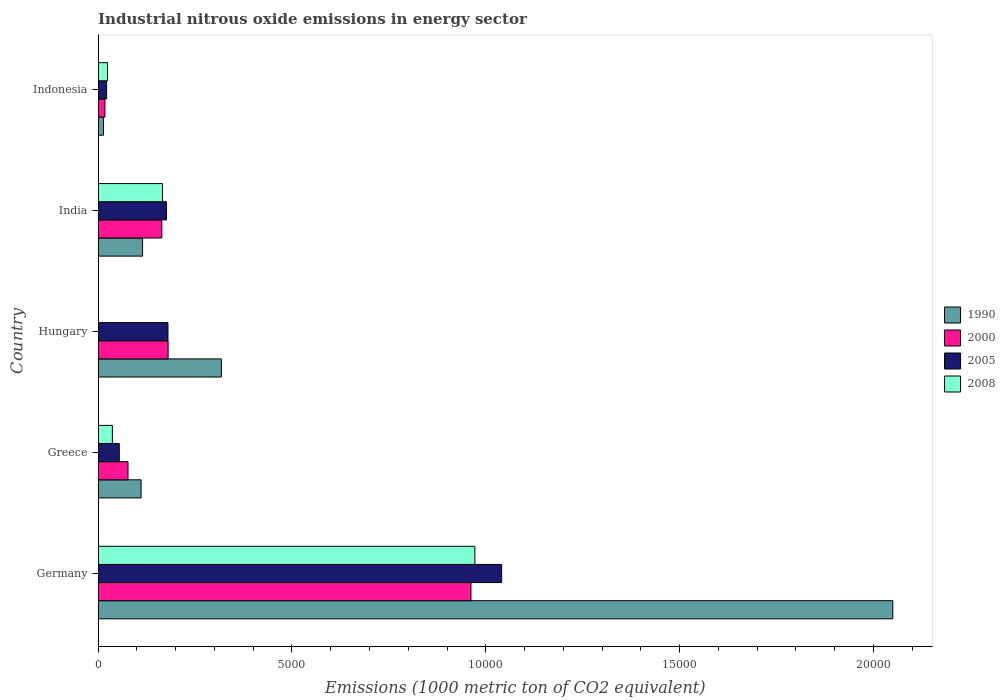How many bars are there on the 3rd tick from the top?
Your answer should be very brief. 4. How many bars are there on the 5th tick from the bottom?
Offer a terse response. 4. What is the label of the 2nd group of bars from the top?
Provide a short and direct response. India. In how many cases, is the number of bars for a given country not equal to the number of legend labels?
Give a very brief answer. 0. What is the amount of industrial nitrous oxide emitted in 2005 in Greece?
Ensure brevity in your answer.  545.8. Across all countries, what is the maximum amount of industrial nitrous oxide emitted in 1990?
Ensure brevity in your answer.  2.05e+04. Across all countries, what is the minimum amount of industrial nitrous oxide emitted in 1990?
Provide a short and direct response. 139.5. In which country was the amount of industrial nitrous oxide emitted in 1990 minimum?
Your answer should be very brief. Indonesia. What is the total amount of industrial nitrous oxide emitted in 2005 in the graph?
Provide a short and direct response. 1.47e+04. What is the difference between the amount of industrial nitrous oxide emitted in 2005 in India and that in Indonesia?
Offer a terse response. 1542.3. What is the difference between the amount of industrial nitrous oxide emitted in 1990 in Greece and the amount of industrial nitrous oxide emitted in 2000 in Germany?
Offer a very short reply. -8508.8. What is the average amount of industrial nitrous oxide emitted in 2000 per country?
Give a very brief answer. 2802.68. What is the difference between the amount of industrial nitrous oxide emitted in 1990 and amount of industrial nitrous oxide emitted in 2000 in India?
Your answer should be very brief. -496.6. In how many countries, is the amount of industrial nitrous oxide emitted in 2008 greater than 8000 1000 metric ton?
Provide a short and direct response. 1. What is the ratio of the amount of industrial nitrous oxide emitted in 1990 in Germany to that in Greece?
Make the answer very short. 18.48. What is the difference between the highest and the second highest amount of industrial nitrous oxide emitted in 2008?
Provide a short and direct response. 8058.6. What is the difference between the highest and the lowest amount of industrial nitrous oxide emitted in 1990?
Make the answer very short. 2.04e+04. Is it the case that in every country, the sum of the amount of industrial nitrous oxide emitted in 2000 and amount of industrial nitrous oxide emitted in 2008 is greater than the sum of amount of industrial nitrous oxide emitted in 2005 and amount of industrial nitrous oxide emitted in 1990?
Provide a short and direct response. No. What does the 4th bar from the top in India represents?
Give a very brief answer. 1990. What does the 4th bar from the bottom in Indonesia represents?
Provide a short and direct response. 2008. Is it the case that in every country, the sum of the amount of industrial nitrous oxide emitted in 1990 and amount of industrial nitrous oxide emitted in 2008 is greater than the amount of industrial nitrous oxide emitted in 2005?
Your response must be concise. Yes. How many bars are there?
Your answer should be compact. 20. Are all the bars in the graph horizontal?
Keep it short and to the point. Yes. Does the graph contain grids?
Offer a terse response. No. Where does the legend appear in the graph?
Your response must be concise. Center right. What is the title of the graph?
Your response must be concise. Industrial nitrous oxide emissions in energy sector. Does "2002" appear as one of the legend labels in the graph?
Your response must be concise. No. What is the label or title of the X-axis?
Keep it short and to the point. Emissions (1000 metric ton of CO2 equivalent). What is the label or title of the Y-axis?
Your answer should be compact. Country. What is the Emissions (1000 metric ton of CO2 equivalent) in 1990 in Germany?
Offer a terse response. 2.05e+04. What is the Emissions (1000 metric ton of CO2 equivalent) in 2000 in Germany?
Ensure brevity in your answer.  9617.9. What is the Emissions (1000 metric ton of CO2 equivalent) of 2005 in Germany?
Offer a very short reply. 1.04e+04. What is the Emissions (1000 metric ton of CO2 equivalent) of 2008 in Germany?
Offer a very short reply. 9718.4. What is the Emissions (1000 metric ton of CO2 equivalent) of 1990 in Greece?
Your answer should be very brief. 1109.1. What is the Emissions (1000 metric ton of CO2 equivalent) in 2000 in Greece?
Ensure brevity in your answer.  771. What is the Emissions (1000 metric ton of CO2 equivalent) of 2005 in Greece?
Offer a very short reply. 545.8. What is the Emissions (1000 metric ton of CO2 equivalent) in 2008 in Greece?
Your response must be concise. 367.4. What is the Emissions (1000 metric ton of CO2 equivalent) of 1990 in Hungary?
Keep it short and to the point. 3178.6. What is the Emissions (1000 metric ton of CO2 equivalent) of 2000 in Hungary?
Offer a very short reply. 1805.4. What is the Emissions (1000 metric ton of CO2 equivalent) of 2005 in Hungary?
Keep it short and to the point. 1802. What is the Emissions (1000 metric ton of CO2 equivalent) in 2008 in Hungary?
Your answer should be compact. 6. What is the Emissions (1000 metric ton of CO2 equivalent) in 1990 in India?
Your answer should be compact. 1146.7. What is the Emissions (1000 metric ton of CO2 equivalent) of 2000 in India?
Provide a short and direct response. 1643.3. What is the Emissions (1000 metric ton of CO2 equivalent) in 2005 in India?
Provide a short and direct response. 1761.9. What is the Emissions (1000 metric ton of CO2 equivalent) in 2008 in India?
Offer a very short reply. 1659.8. What is the Emissions (1000 metric ton of CO2 equivalent) of 1990 in Indonesia?
Keep it short and to the point. 139.5. What is the Emissions (1000 metric ton of CO2 equivalent) in 2000 in Indonesia?
Your answer should be very brief. 175.8. What is the Emissions (1000 metric ton of CO2 equivalent) of 2005 in Indonesia?
Keep it short and to the point. 219.6. What is the Emissions (1000 metric ton of CO2 equivalent) in 2008 in Indonesia?
Offer a very short reply. 243.3. Across all countries, what is the maximum Emissions (1000 metric ton of CO2 equivalent) of 1990?
Offer a terse response. 2.05e+04. Across all countries, what is the maximum Emissions (1000 metric ton of CO2 equivalent) of 2000?
Ensure brevity in your answer.  9617.9. Across all countries, what is the maximum Emissions (1000 metric ton of CO2 equivalent) in 2005?
Your answer should be very brief. 1.04e+04. Across all countries, what is the maximum Emissions (1000 metric ton of CO2 equivalent) of 2008?
Provide a short and direct response. 9718.4. Across all countries, what is the minimum Emissions (1000 metric ton of CO2 equivalent) of 1990?
Provide a short and direct response. 139.5. Across all countries, what is the minimum Emissions (1000 metric ton of CO2 equivalent) in 2000?
Ensure brevity in your answer.  175.8. Across all countries, what is the minimum Emissions (1000 metric ton of CO2 equivalent) of 2005?
Give a very brief answer. 219.6. What is the total Emissions (1000 metric ton of CO2 equivalent) in 1990 in the graph?
Your answer should be very brief. 2.61e+04. What is the total Emissions (1000 metric ton of CO2 equivalent) in 2000 in the graph?
Make the answer very short. 1.40e+04. What is the total Emissions (1000 metric ton of CO2 equivalent) of 2005 in the graph?
Offer a terse response. 1.47e+04. What is the total Emissions (1000 metric ton of CO2 equivalent) in 2008 in the graph?
Offer a terse response. 1.20e+04. What is the difference between the Emissions (1000 metric ton of CO2 equivalent) in 1990 in Germany and that in Greece?
Keep it short and to the point. 1.94e+04. What is the difference between the Emissions (1000 metric ton of CO2 equivalent) of 2000 in Germany and that in Greece?
Offer a terse response. 8846.9. What is the difference between the Emissions (1000 metric ton of CO2 equivalent) of 2005 in Germany and that in Greece?
Your answer should be compact. 9863.1. What is the difference between the Emissions (1000 metric ton of CO2 equivalent) of 2008 in Germany and that in Greece?
Your response must be concise. 9351. What is the difference between the Emissions (1000 metric ton of CO2 equivalent) of 1990 in Germany and that in Hungary?
Provide a succinct answer. 1.73e+04. What is the difference between the Emissions (1000 metric ton of CO2 equivalent) in 2000 in Germany and that in Hungary?
Provide a short and direct response. 7812.5. What is the difference between the Emissions (1000 metric ton of CO2 equivalent) of 2005 in Germany and that in Hungary?
Make the answer very short. 8606.9. What is the difference between the Emissions (1000 metric ton of CO2 equivalent) of 2008 in Germany and that in Hungary?
Provide a succinct answer. 9712.4. What is the difference between the Emissions (1000 metric ton of CO2 equivalent) in 1990 in Germany and that in India?
Offer a terse response. 1.94e+04. What is the difference between the Emissions (1000 metric ton of CO2 equivalent) of 2000 in Germany and that in India?
Provide a succinct answer. 7974.6. What is the difference between the Emissions (1000 metric ton of CO2 equivalent) of 2005 in Germany and that in India?
Make the answer very short. 8647. What is the difference between the Emissions (1000 metric ton of CO2 equivalent) in 2008 in Germany and that in India?
Ensure brevity in your answer.  8058.6. What is the difference between the Emissions (1000 metric ton of CO2 equivalent) in 1990 in Germany and that in Indonesia?
Provide a short and direct response. 2.04e+04. What is the difference between the Emissions (1000 metric ton of CO2 equivalent) in 2000 in Germany and that in Indonesia?
Provide a succinct answer. 9442.1. What is the difference between the Emissions (1000 metric ton of CO2 equivalent) in 2005 in Germany and that in Indonesia?
Give a very brief answer. 1.02e+04. What is the difference between the Emissions (1000 metric ton of CO2 equivalent) in 2008 in Germany and that in Indonesia?
Give a very brief answer. 9475.1. What is the difference between the Emissions (1000 metric ton of CO2 equivalent) of 1990 in Greece and that in Hungary?
Your answer should be compact. -2069.5. What is the difference between the Emissions (1000 metric ton of CO2 equivalent) in 2000 in Greece and that in Hungary?
Make the answer very short. -1034.4. What is the difference between the Emissions (1000 metric ton of CO2 equivalent) in 2005 in Greece and that in Hungary?
Keep it short and to the point. -1256.2. What is the difference between the Emissions (1000 metric ton of CO2 equivalent) in 2008 in Greece and that in Hungary?
Provide a succinct answer. 361.4. What is the difference between the Emissions (1000 metric ton of CO2 equivalent) in 1990 in Greece and that in India?
Your response must be concise. -37.6. What is the difference between the Emissions (1000 metric ton of CO2 equivalent) of 2000 in Greece and that in India?
Provide a short and direct response. -872.3. What is the difference between the Emissions (1000 metric ton of CO2 equivalent) in 2005 in Greece and that in India?
Provide a short and direct response. -1216.1. What is the difference between the Emissions (1000 metric ton of CO2 equivalent) of 2008 in Greece and that in India?
Offer a very short reply. -1292.4. What is the difference between the Emissions (1000 metric ton of CO2 equivalent) in 1990 in Greece and that in Indonesia?
Give a very brief answer. 969.6. What is the difference between the Emissions (1000 metric ton of CO2 equivalent) in 2000 in Greece and that in Indonesia?
Offer a terse response. 595.2. What is the difference between the Emissions (1000 metric ton of CO2 equivalent) of 2005 in Greece and that in Indonesia?
Ensure brevity in your answer.  326.2. What is the difference between the Emissions (1000 metric ton of CO2 equivalent) of 2008 in Greece and that in Indonesia?
Your response must be concise. 124.1. What is the difference between the Emissions (1000 metric ton of CO2 equivalent) in 1990 in Hungary and that in India?
Ensure brevity in your answer.  2031.9. What is the difference between the Emissions (1000 metric ton of CO2 equivalent) of 2000 in Hungary and that in India?
Ensure brevity in your answer.  162.1. What is the difference between the Emissions (1000 metric ton of CO2 equivalent) in 2005 in Hungary and that in India?
Keep it short and to the point. 40.1. What is the difference between the Emissions (1000 metric ton of CO2 equivalent) of 2008 in Hungary and that in India?
Provide a short and direct response. -1653.8. What is the difference between the Emissions (1000 metric ton of CO2 equivalent) in 1990 in Hungary and that in Indonesia?
Offer a terse response. 3039.1. What is the difference between the Emissions (1000 metric ton of CO2 equivalent) in 2000 in Hungary and that in Indonesia?
Provide a succinct answer. 1629.6. What is the difference between the Emissions (1000 metric ton of CO2 equivalent) of 2005 in Hungary and that in Indonesia?
Your answer should be compact. 1582.4. What is the difference between the Emissions (1000 metric ton of CO2 equivalent) of 2008 in Hungary and that in Indonesia?
Make the answer very short. -237.3. What is the difference between the Emissions (1000 metric ton of CO2 equivalent) in 1990 in India and that in Indonesia?
Keep it short and to the point. 1007.2. What is the difference between the Emissions (1000 metric ton of CO2 equivalent) of 2000 in India and that in Indonesia?
Your answer should be compact. 1467.5. What is the difference between the Emissions (1000 metric ton of CO2 equivalent) of 2005 in India and that in Indonesia?
Offer a very short reply. 1542.3. What is the difference between the Emissions (1000 metric ton of CO2 equivalent) of 2008 in India and that in Indonesia?
Give a very brief answer. 1416.5. What is the difference between the Emissions (1000 metric ton of CO2 equivalent) in 1990 in Germany and the Emissions (1000 metric ton of CO2 equivalent) in 2000 in Greece?
Your response must be concise. 1.97e+04. What is the difference between the Emissions (1000 metric ton of CO2 equivalent) of 1990 in Germany and the Emissions (1000 metric ton of CO2 equivalent) of 2005 in Greece?
Offer a terse response. 2.00e+04. What is the difference between the Emissions (1000 metric ton of CO2 equivalent) of 1990 in Germany and the Emissions (1000 metric ton of CO2 equivalent) of 2008 in Greece?
Give a very brief answer. 2.01e+04. What is the difference between the Emissions (1000 metric ton of CO2 equivalent) of 2000 in Germany and the Emissions (1000 metric ton of CO2 equivalent) of 2005 in Greece?
Offer a very short reply. 9072.1. What is the difference between the Emissions (1000 metric ton of CO2 equivalent) of 2000 in Germany and the Emissions (1000 metric ton of CO2 equivalent) of 2008 in Greece?
Keep it short and to the point. 9250.5. What is the difference between the Emissions (1000 metric ton of CO2 equivalent) of 2005 in Germany and the Emissions (1000 metric ton of CO2 equivalent) of 2008 in Greece?
Your response must be concise. 1.00e+04. What is the difference between the Emissions (1000 metric ton of CO2 equivalent) in 1990 in Germany and the Emissions (1000 metric ton of CO2 equivalent) in 2000 in Hungary?
Your response must be concise. 1.87e+04. What is the difference between the Emissions (1000 metric ton of CO2 equivalent) in 1990 in Germany and the Emissions (1000 metric ton of CO2 equivalent) in 2005 in Hungary?
Provide a short and direct response. 1.87e+04. What is the difference between the Emissions (1000 metric ton of CO2 equivalent) of 1990 in Germany and the Emissions (1000 metric ton of CO2 equivalent) of 2008 in Hungary?
Ensure brevity in your answer.  2.05e+04. What is the difference between the Emissions (1000 metric ton of CO2 equivalent) of 2000 in Germany and the Emissions (1000 metric ton of CO2 equivalent) of 2005 in Hungary?
Offer a terse response. 7815.9. What is the difference between the Emissions (1000 metric ton of CO2 equivalent) of 2000 in Germany and the Emissions (1000 metric ton of CO2 equivalent) of 2008 in Hungary?
Make the answer very short. 9611.9. What is the difference between the Emissions (1000 metric ton of CO2 equivalent) of 2005 in Germany and the Emissions (1000 metric ton of CO2 equivalent) of 2008 in Hungary?
Ensure brevity in your answer.  1.04e+04. What is the difference between the Emissions (1000 metric ton of CO2 equivalent) in 1990 in Germany and the Emissions (1000 metric ton of CO2 equivalent) in 2000 in India?
Keep it short and to the point. 1.89e+04. What is the difference between the Emissions (1000 metric ton of CO2 equivalent) of 1990 in Germany and the Emissions (1000 metric ton of CO2 equivalent) of 2005 in India?
Provide a succinct answer. 1.87e+04. What is the difference between the Emissions (1000 metric ton of CO2 equivalent) in 1990 in Germany and the Emissions (1000 metric ton of CO2 equivalent) in 2008 in India?
Ensure brevity in your answer.  1.88e+04. What is the difference between the Emissions (1000 metric ton of CO2 equivalent) in 2000 in Germany and the Emissions (1000 metric ton of CO2 equivalent) in 2005 in India?
Your answer should be very brief. 7856. What is the difference between the Emissions (1000 metric ton of CO2 equivalent) of 2000 in Germany and the Emissions (1000 metric ton of CO2 equivalent) of 2008 in India?
Offer a terse response. 7958.1. What is the difference between the Emissions (1000 metric ton of CO2 equivalent) of 2005 in Germany and the Emissions (1000 metric ton of CO2 equivalent) of 2008 in India?
Make the answer very short. 8749.1. What is the difference between the Emissions (1000 metric ton of CO2 equivalent) of 1990 in Germany and the Emissions (1000 metric ton of CO2 equivalent) of 2000 in Indonesia?
Your response must be concise. 2.03e+04. What is the difference between the Emissions (1000 metric ton of CO2 equivalent) in 1990 in Germany and the Emissions (1000 metric ton of CO2 equivalent) in 2005 in Indonesia?
Keep it short and to the point. 2.03e+04. What is the difference between the Emissions (1000 metric ton of CO2 equivalent) in 1990 in Germany and the Emissions (1000 metric ton of CO2 equivalent) in 2008 in Indonesia?
Your answer should be compact. 2.03e+04. What is the difference between the Emissions (1000 metric ton of CO2 equivalent) in 2000 in Germany and the Emissions (1000 metric ton of CO2 equivalent) in 2005 in Indonesia?
Offer a terse response. 9398.3. What is the difference between the Emissions (1000 metric ton of CO2 equivalent) of 2000 in Germany and the Emissions (1000 metric ton of CO2 equivalent) of 2008 in Indonesia?
Offer a terse response. 9374.6. What is the difference between the Emissions (1000 metric ton of CO2 equivalent) of 2005 in Germany and the Emissions (1000 metric ton of CO2 equivalent) of 2008 in Indonesia?
Ensure brevity in your answer.  1.02e+04. What is the difference between the Emissions (1000 metric ton of CO2 equivalent) of 1990 in Greece and the Emissions (1000 metric ton of CO2 equivalent) of 2000 in Hungary?
Give a very brief answer. -696.3. What is the difference between the Emissions (1000 metric ton of CO2 equivalent) of 1990 in Greece and the Emissions (1000 metric ton of CO2 equivalent) of 2005 in Hungary?
Provide a short and direct response. -692.9. What is the difference between the Emissions (1000 metric ton of CO2 equivalent) in 1990 in Greece and the Emissions (1000 metric ton of CO2 equivalent) in 2008 in Hungary?
Offer a terse response. 1103.1. What is the difference between the Emissions (1000 metric ton of CO2 equivalent) in 2000 in Greece and the Emissions (1000 metric ton of CO2 equivalent) in 2005 in Hungary?
Give a very brief answer. -1031. What is the difference between the Emissions (1000 metric ton of CO2 equivalent) of 2000 in Greece and the Emissions (1000 metric ton of CO2 equivalent) of 2008 in Hungary?
Give a very brief answer. 765. What is the difference between the Emissions (1000 metric ton of CO2 equivalent) of 2005 in Greece and the Emissions (1000 metric ton of CO2 equivalent) of 2008 in Hungary?
Your response must be concise. 539.8. What is the difference between the Emissions (1000 metric ton of CO2 equivalent) in 1990 in Greece and the Emissions (1000 metric ton of CO2 equivalent) in 2000 in India?
Offer a very short reply. -534.2. What is the difference between the Emissions (1000 metric ton of CO2 equivalent) in 1990 in Greece and the Emissions (1000 metric ton of CO2 equivalent) in 2005 in India?
Ensure brevity in your answer.  -652.8. What is the difference between the Emissions (1000 metric ton of CO2 equivalent) of 1990 in Greece and the Emissions (1000 metric ton of CO2 equivalent) of 2008 in India?
Provide a short and direct response. -550.7. What is the difference between the Emissions (1000 metric ton of CO2 equivalent) of 2000 in Greece and the Emissions (1000 metric ton of CO2 equivalent) of 2005 in India?
Make the answer very short. -990.9. What is the difference between the Emissions (1000 metric ton of CO2 equivalent) in 2000 in Greece and the Emissions (1000 metric ton of CO2 equivalent) in 2008 in India?
Your response must be concise. -888.8. What is the difference between the Emissions (1000 metric ton of CO2 equivalent) in 2005 in Greece and the Emissions (1000 metric ton of CO2 equivalent) in 2008 in India?
Provide a succinct answer. -1114. What is the difference between the Emissions (1000 metric ton of CO2 equivalent) in 1990 in Greece and the Emissions (1000 metric ton of CO2 equivalent) in 2000 in Indonesia?
Provide a succinct answer. 933.3. What is the difference between the Emissions (1000 metric ton of CO2 equivalent) in 1990 in Greece and the Emissions (1000 metric ton of CO2 equivalent) in 2005 in Indonesia?
Provide a short and direct response. 889.5. What is the difference between the Emissions (1000 metric ton of CO2 equivalent) of 1990 in Greece and the Emissions (1000 metric ton of CO2 equivalent) of 2008 in Indonesia?
Offer a terse response. 865.8. What is the difference between the Emissions (1000 metric ton of CO2 equivalent) of 2000 in Greece and the Emissions (1000 metric ton of CO2 equivalent) of 2005 in Indonesia?
Provide a short and direct response. 551.4. What is the difference between the Emissions (1000 metric ton of CO2 equivalent) of 2000 in Greece and the Emissions (1000 metric ton of CO2 equivalent) of 2008 in Indonesia?
Ensure brevity in your answer.  527.7. What is the difference between the Emissions (1000 metric ton of CO2 equivalent) of 2005 in Greece and the Emissions (1000 metric ton of CO2 equivalent) of 2008 in Indonesia?
Keep it short and to the point. 302.5. What is the difference between the Emissions (1000 metric ton of CO2 equivalent) in 1990 in Hungary and the Emissions (1000 metric ton of CO2 equivalent) in 2000 in India?
Your answer should be compact. 1535.3. What is the difference between the Emissions (1000 metric ton of CO2 equivalent) in 1990 in Hungary and the Emissions (1000 metric ton of CO2 equivalent) in 2005 in India?
Offer a terse response. 1416.7. What is the difference between the Emissions (1000 metric ton of CO2 equivalent) in 1990 in Hungary and the Emissions (1000 metric ton of CO2 equivalent) in 2008 in India?
Provide a short and direct response. 1518.8. What is the difference between the Emissions (1000 metric ton of CO2 equivalent) in 2000 in Hungary and the Emissions (1000 metric ton of CO2 equivalent) in 2005 in India?
Your answer should be compact. 43.5. What is the difference between the Emissions (1000 metric ton of CO2 equivalent) in 2000 in Hungary and the Emissions (1000 metric ton of CO2 equivalent) in 2008 in India?
Your answer should be very brief. 145.6. What is the difference between the Emissions (1000 metric ton of CO2 equivalent) in 2005 in Hungary and the Emissions (1000 metric ton of CO2 equivalent) in 2008 in India?
Your response must be concise. 142.2. What is the difference between the Emissions (1000 metric ton of CO2 equivalent) of 1990 in Hungary and the Emissions (1000 metric ton of CO2 equivalent) of 2000 in Indonesia?
Keep it short and to the point. 3002.8. What is the difference between the Emissions (1000 metric ton of CO2 equivalent) in 1990 in Hungary and the Emissions (1000 metric ton of CO2 equivalent) in 2005 in Indonesia?
Offer a terse response. 2959. What is the difference between the Emissions (1000 metric ton of CO2 equivalent) in 1990 in Hungary and the Emissions (1000 metric ton of CO2 equivalent) in 2008 in Indonesia?
Offer a terse response. 2935.3. What is the difference between the Emissions (1000 metric ton of CO2 equivalent) in 2000 in Hungary and the Emissions (1000 metric ton of CO2 equivalent) in 2005 in Indonesia?
Your answer should be compact. 1585.8. What is the difference between the Emissions (1000 metric ton of CO2 equivalent) of 2000 in Hungary and the Emissions (1000 metric ton of CO2 equivalent) of 2008 in Indonesia?
Provide a short and direct response. 1562.1. What is the difference between the Emissions (1000 metric ton of CO2 equivalent) in 2005 in Hungary and the Emissions (1000 metric ton of CO2 equivalent) in 2008 in Indonesia?
Your answer should be very brief. 1558.7. What is the difference between the Emissions (1000 metric ton of CO2 equivalent) of 1990 in India and the Emissions (1000 metric ton of CO2 equivalent) of 2000 in Indonesia?
Your answer should be compact. 970.9. What is the difference between the Emissions (1000 metric ton of CO2 equivalent) of 1990 in India and the Emissions (1000 metric ton of CO2 equivalent) of 2005 in Indonesia?
Your answer should be very brief. 927.1. What is the difference between the Emissions (1000 metric ton of CO2 equivalent) of 1990 in India and the Emissions (1000 metric ton of CO2 equivalent) of 2008 in Indonesia?
Make the answer very short. 903.4. What is the difference between the Emissions (1000 metric ton of CO2 equivalent) in 2000 in India and the Emissions (1000 metric ton of CO2 equivalent) in 2005 in Indonesia?
Provide a short and direct response. 1423.7. What is the difference between the Emissions (1000 metric ton of CO2 equivalent) of 2000 in India and the Emissions (1000 metric ton of CO2 equivalent) of 2008 in Indonesia?
Offer a very short reply. 1400. What is the difference between the Emissions (1000 metric ton of CO2 equivalent) in 2005 in India and the Emissions (1000 metric ton of CO2 equivalent) in 2008 in Indonesia?
Make the answer very short. 1518.6. What is the average Emissions (1000 metric ton of CO2 equivalent) of 1990 per country?
Provide a short and direct response. 5214.7. What is the average Emissions (1000 metric ton of CO2 equivalent) in 2000 per country?
Give a very brief answer. 2802.68. What is the average Emissions (1000 metric ton of CO2 equivalent) in 2005 per country?
Provide a succinct answer. 2947.64. What is the average Emissions (1000 metric ton of CO2 equivalent) of 2008 per country?
Your answer should be compact. 2398.98. What is the difference between the Emissions (1000 metric ton of CO2 equivalent) of 1990 and Emissions (1000 metric ton of CO2 equivalent) of 2000 in Germany?
Give a very brief answer. 1.09e+04. What is the difference between the Emissions (1000 metric ton of CO2 equivalent) of 1990 and Emissions (1000 metric ton of CO2 equivalent) of 2005 in Germany?
Keep it short and to the point. 1.01e+04. What is the difference between the Emissions (1000 metric ton of CO2 equivalent) of 1990 and Emissions (1000 metric ton of CO2 equivalent) of 2008 in Germany?
Ensure brevity in your answer.  1.08e+04. What is the difference between the Emissions (1000 metric ton of CO2 equivalent) in 2000 and Emissions (1000 metric ton of CO2 equivalent) in 2005 in Germany?
Your response must be concise. -791. What is the difference between the Emissions (1000 metric ton of CO2 equivalent) of 2000 and Emissions (1000 metric ton of CO2 equivalent) of 2008 in Germany?
Your answer should be compact. -100.5. What is the difference between the Emissions (1000 metric ton of CO2 equivalent) of 2005 and Emissions (1000 metric ton of CO2 equivalent) of 2008 in Germany?
Give a very brief answer. 690.5. What is the difference between the Emissions (1000 metric ton of CO2 equivalent) in 1990 and Emissions (1000 metric ton of CO2 equivalent) in 2000 in Greece?
Provide a succinct answer. 338.1. What is the difference between the Emissions (1000 metric ton of CO2 equivalent) of 1990 and Emissions (1000 metric ton of CO2 equivalent) of 2005 in Greece?
Your answer should be compact. 563.3. What is the difference between the Emissions (1000 metric ton of CO2 equivalent) in 1990 and Emissions (1000 metric ton of CO2 equivalent) in 2008 in Greece?
Your response must be concise. 741.7. What is the difference between the Emissions (1000 metric ton of CO2 equivalent) in 2000 and Emissions (1000 metric ton of CO2 equivalent) in 2005 in Greece?
Your answer should be very brief. 225.2. What is the difference between the Emissions (1000 metric ton of CO2 equivalent) in 2000 and Emissions (1000 metric ton of CO2 equivalent) in 2008 in Greece?
Keep it short and to the point. 403.6. What is the difference between the Emissions (1000 metric ton of CO2 equivalent) in 2005 and Emissions (1000 metric ton of CO2 equivalent) in 2008 in Greece?
Provide a succinct answer. 178.4. What is the difference between the Emissions (1000 metric ton of CO2 equivalent) of 1990 and Emissions (1000 metric ton of CO2 equivalent) of 2000 in Hungary?
Make the answer very short. 1373.2. What is the difference between the Emissions (1000 metric ton of CO2 equivalent) in 1990 and Emissions (1000 metric ton of CO2 equivalent) in 2005 in Hungary?
Offer a very short reply. 1376.6. What is the difference between the Emissions (1000 metric ton of CO2 equivalent) in 1990 and Emissions (1000 metric ton of CO2 equivalent) in 2008 in Hungary?
Your answer should be compact. 3172.6. What is the difference between the Emissions (1000 metric ton of CO2 equivalent) in 2000 and Emissions (1000 metric ton of CO2 equivalent) in 2005 in Hungary?
Provide a short and direct response. 3.4. What is the difference between the Emissions (1000 metric ton of CO2 equivalent) of 2000 and Emissions (1000 metric ton of CO2 equivalent) of 2008 in Hungary?
Ensure brevity in your answer.  1799.4. What is the difference between the Emissions (1000 metric ton of CO2 equivalent) in 2005 and Emissions (1000 metric ton of CO2 equivalent) in 2008 in Hungary?
Your response must be concise. 1796. What is the difference between the Emissions (1000 metric ton of CO2 equivalent) of 1990 and Emissions (1000 metric ton of CO2 equivalent) of 2000 in India?
Keep it short and to the point. -496.6. What is the difference between the Emissions (1000 metric ton of CO2 equivalent) in 1990 and Emissions (1000 metric ton of CO2 equivalent) in 2005 in India?
Your answer should be very brief. -615.2. What is the difference between the Emissions (1000 metric ton of CO2 equivalent) in 1990 and Emissions (1000 metric ton of CO2 equivalent) in 2008 in India?
Your response must be concise. -513.1. What is the difference between the Emissions (1000 metric ton of CO2 equivalent) of 2000 and Emissions (1000 metric ton of CO2 equivalent) of 2005 in India?
Give a very brief answer. -118.6. What is the difference between the Emissions (1000 metric ton of CO2 equivalent) in 2000 and Emissions (1000 metric ton of CO2 equivalent) in 2008 in India?
Ensure brevity in your answer.  -16.5. What is the difference between the Emissions (1000 metric ton of CO2 equivalent) of 2005 and Emissions (1000 metric ton of CO2 equivalent) of 2008 in India?
Provide a succinct answer. 102.1. What is the difference between the Emissions (1000 metric ton of CO2 equivalent) in 1990 and Emissions (1000 metric ton of CO2 equivalent) in 2000 in Indonesia?
Ensure brevity in your answer.  -36.3. What is the difference between the Emissions (1000 metric ton of CO2 equivalent) in 1990 and Emissions (1000 metric ton of CO2 equivalent) in 2005 in Indonesia?
Offer a very short reply. -80.1. What is the difference between the Emissions (1000 metric ton of CO2 equivalent) of 1990 and Emissions (1000 metric ton of CO2 equivalent) of 2008 in Indonesia?
Ensure brevity in your answer.  -103.8. What is the difference between the Emissions (1000 metric ton of CO2 equivalent) of 2000 and Emissions (1000 metric ton of CO2 equivalent) of 2005 in Indonesia?
Keep it short and to the point. -43.8. What is the difference between the Emissions (1000 metric ton of CO2 equivalent) of 2000 and Emissions (1000 metric ton of CO2 equivalent) of 2008 in Indonesia?
Provide a short and direct response. -67.5. What is the difference between the Emissions (1000 metric ton of CO2 equivalent) of 2005 and Emissions (1000 metric ton of CO2 equivalent) of 2008 in Indonesia?
Your answer should be compact. -23.7. What is the ratio of the Emissions (1000 metric ton of CO2 equivalent) in 1990 in Germany to that in Greece?
Provide a short and direct response. 18.48. What is the ratio of the Emissions (1000 metric ton of CO2 equivalent) of 2000 in Germany to that in Greece?
Provide a short and direct response. 12.47. What is the ratio of the Emissions (1000 metric ton of CO2 equivalent) of 2005 in Germany to that in Greece?
Give a very brief answer. 19.07. What is the ratio of the Emissions (1000 metric ton of CO2 equivalent) in 2008 in Germany to that in Greece?
Offer a terse response. 26.45. What is the ratio of the Emissions (1000 metric ton of CO2 equivalent) in 1990 in Germany to that in Hungary?
Your answer should be very brief. 6.45. What is the ratio of the Emissions (1000 metric ton of CO2 equivalent) in 2000 in Germany to that in Hungary?
Your response must be concise. 5.33. What is the ratio of the Emissions (1000 metric ton of CO2 equivalent) of 2005 in Germany to that in Hungary?
Make the answer very short. 5.78. What is the ratio of the Emissions (1000 metric ton of CO2 equivalent) of 2008 in Germany to that in Hungary?
Your response must be concise. 1619.73. What is the ratio of the Emissions (1000 metric ton of CO2 equivalent) of 1990 in Germany to that in India?
Your answer should be very brief. 17.88. What is the ratio of the Emissions (1000 metric ton of CO2 equivalent) in 2000 in Germany to that in India?
Offer a very short reply. 5.85. What is the ratio of the Emissions (1000 metric ton of CO2 equivalent) of 2005 in Germany to that in India?
Your response must be concise. 5.91. What is the ratio of the Emissions (1000 metric ton of CO2 equivalent) of 2008 in Germany to that in India?
Provide a short and direct response. 5.86. What is the ratio of the Emissions (1000 metric ton of CO2 equivalent) of 1990 in Germany to that in Indonesia?
Your response must be concise. 146.95. What is the ratio of the Emissions (1000 metric ton of CO2 equivalent) in 2000 in Germany to that in Indonesia?
Make the answer very short. 54.71. What is the ratio of the Emissions (1000 metric ton of CO2 equivalent) in 2005 in Germany to that in Indonesia?
Your response must be concise. 47.4. What is the ratio of the Emissions (1000 metric ton of CO2 equivalent) in 2008 in Germany to that in Indonesia?
Your answer should be very brief. 39.94. What is the ratio of the Emissions (1000 metric ton of CO2 equivalent) in 1990 in Greece to that in Hungary?
Ensure brevity in your answer.  0.35. What is the ratio of the Emissions (1000 metric ton of CO2 equivalent) of 2000 in Greece to that in Hungary?
Provide a succinct answer. 0.43. What is the ratio of the Emissions (1000 metric ton of CO2 equivalent) of 2005 in Greece to that in Hungary?
Provide a short and direct response. 0.3. What is the ratio of the Emissions (1000 metric ton of CO2 equivalent) in 2008 in Greece to that in Hungary?
Your answer should be very brief. 61.23. What is the ratio of the Emissions (1000 metric ton of CO2 equivalent) in 1990 in Greece to that in India?
Provide a succinct answer. 0.97. What is the ratio of the Emissions (1000 metric ton of CO2 equivalent) of 2000 in Greece to that in India?
Provide a short and direct response. 0.47. What is the ratio of the Emissions (1000 metric ton of CO2 equivalent) in 2005 in Greece to that in India?
Provide a succinct answer. 0.31. What is the ratio of the Emissions (1000 metric ton of CO2 equivalent) of 2008 in Greece to that in India?
Your answer should be very brief. 0.22. What is the ratio of the Emissions (1000 metric ton of CO2 equivalent) of 1990 in Greece to that in Indonesia?
Your response must be concise. 7.95. What is the ratio of the Emissions (1000 metric ton of CO2 equivalent) of 2000 in Greece to that in Indonesia?
Ensure brevity in your answer.  4.39. What is the ratio of the Emissions (1000 metric ton of CO2 equivalent) of 2005 in Greece to that in Indonesia?
Keep it short and to the point. 2.49. What is the ratio of the Emissions (1000 metric ton of CO2 equivalent) of 2008 in Greece to that in Indonesia?
Make the answer very short. 1.51. What is the ratio of the Emissions (1000 metric ton of CO2 equivalent) of 1990 in Hungary to that in India?
Give a very brief answer. 2.77. What is the ratio of the Emissions (1000 metric ton of CO2 equivalent) of 2000 in Hungary to that in India?
Offer a terse response. 1.1. What is the ratio of the Emissions (1000 metric ton of CO2 equivalent) of 2005 in Hungary to that in India?
Offer a very short reply. 1.02. What is the ratio of the Emissions (1000 metric ton of CO2 equivalent) of 2008 in Hungary to that in India?
Ensure brevity in your answer.  0. What is the ratio of the Emissions (1000 metric ton of CO2 equivalent) of 1990 in Hungary to that in Indonesia?
Your response must be concise. 22.79. What is the ratio of the Emissions (1000 metric ton of CO2 equivalent) of 2000 in Hungary to that in Indonesia?
Offer a very short reply. 10.27. What is the ratio of the Emissions (1000 metric ton of CO2 equivalent) in 2005 in Hungary to that in Indonesia?
Keep it short and to the point. 8.21. What is the ratio of the Emissions (1000 metric ton of CO2 equivalent) in 2008 in Hungary to that in Indonesia?
Your response must be concise. 0.02. What is the ratio of the Emissions (1000 metric ton of CO2 equivalent) in 1990 in India to that in Indonesia?
Your response must be concise. 8.22. What is the ratio of the Emissions (1000 metric ton of CO2 equivalent) in 2000 in India to that in Indonesia?
Give a very brief answer. 9.35. What is the ratio of the Emissions (1000 metric ton of CO2 equivalent) in 2005 in India to that in Indonesia?
Provide a short and direct response. 8.02. What is the ratio of the Emissions (1000 metric ton of CO2 equivalent) of 2008 in India to that in Indonesia?
Provide a succinct answer. 6.82. What is the difference between the highest and the second highest Emissions (1000 metric ton of CO2 equivalent) of 1990?
Provide a short and direct response. 1.73e+04. What is the difference between the highest and the second highest Emissions (1000 metric ton of CO2 equivalent) in 2000?
Ensure brevity in your answer.  7812.5. What is the difference between the highest and the second highest Emissions (1000 metric ton of CO2 equivalent) in 2005?
Make the answer very short. 8606.9. What is the difference between the highest and the second highest Emissions (1000 metric ton of CO2 equivalent) in 2008?
Your answer should be very brief. 8058.6. What is the difference between the highest and the lowest Emissions (1000 metric ton of CO2 equivalent) in 1990?
Offer a very short reply. 2.04e+04. What is the difference between the highest and the lowest Emissions (1000 metric ton of CO2 equivalent) of 2000?
Ensure brevity in your answer.  9442.1. What is the difference between the highest and the lowest Emissions (1000 metric ton of CO2 equivalent) of 2005?
Provide a succinct answer. 1.02e+04. What is the difference between the highest and the lowest Emissions (1000 metric ton of CO2 equivalent) in 2008?
Offer a terse response. 9712.4. 